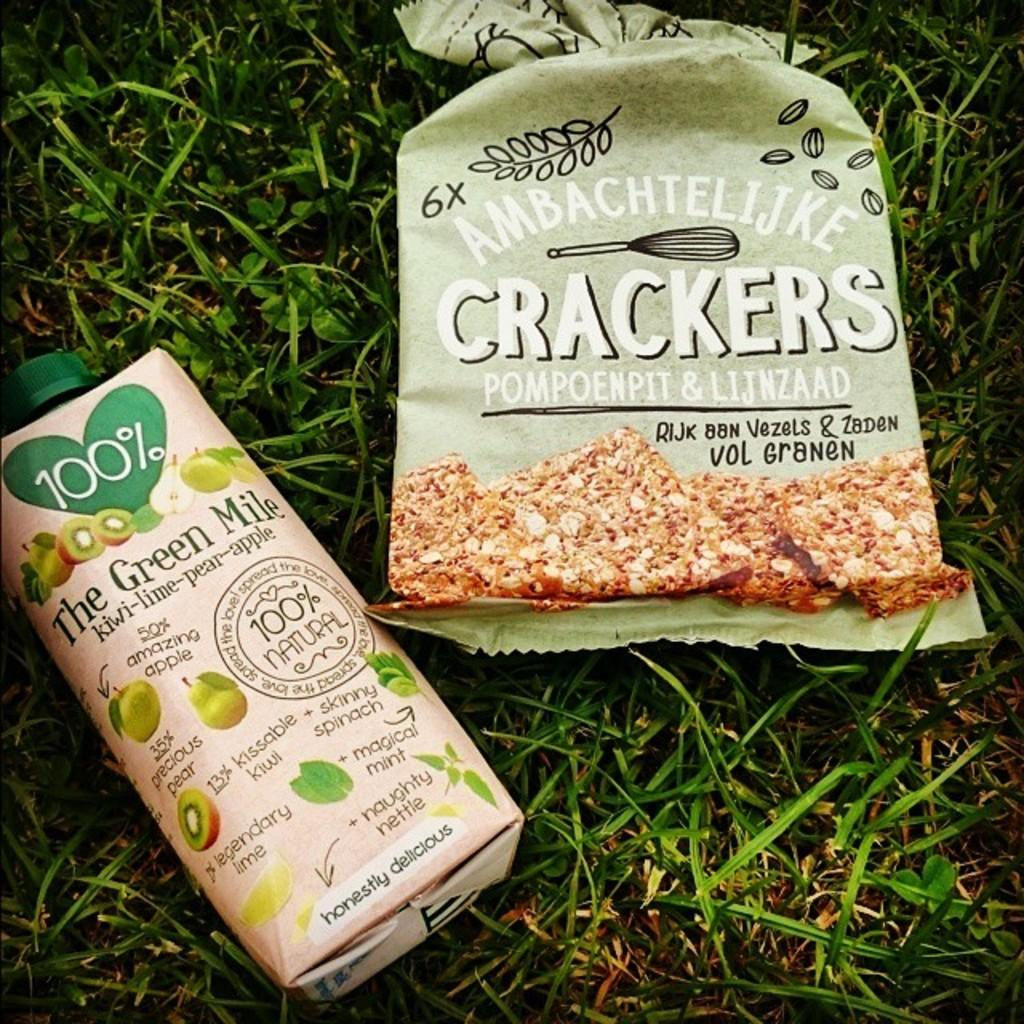Provide a one-sentence caption for the provided image. A package of Ambachtellijke Crackers next to a bottle of juice. 